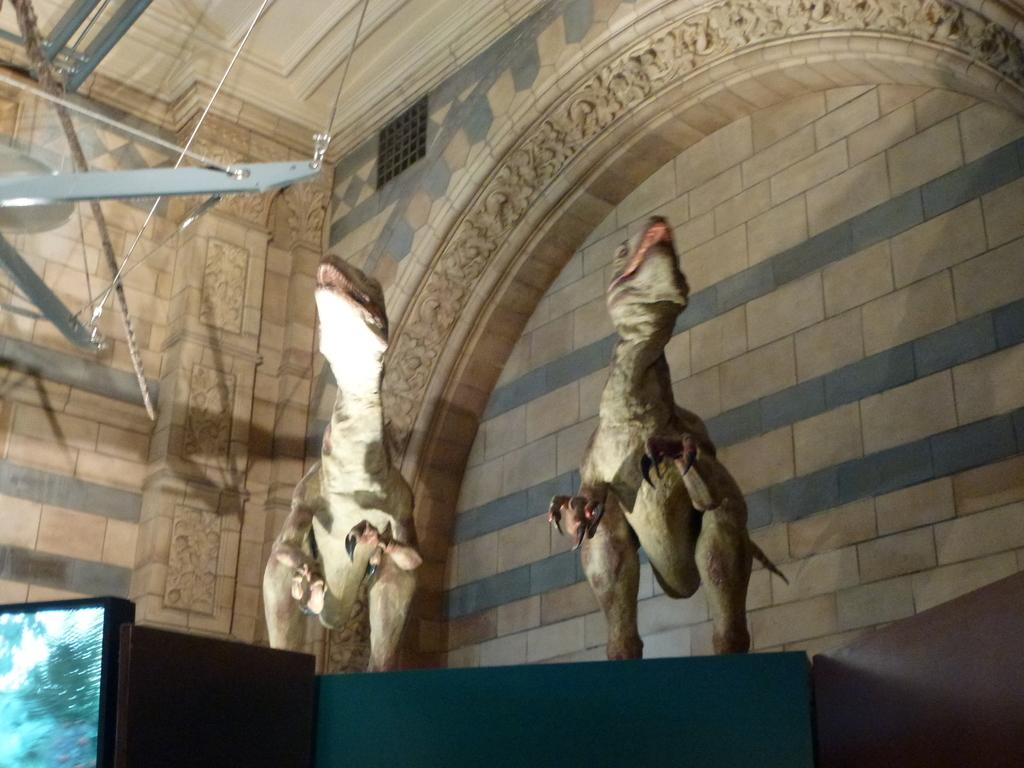What type of objects are depicted in the image? There are sculptures of dinosaurs in the image. What can be seen in the background of the image? There is a wall in the background of the image. What direction is the pan facing in the image? There is no pan present in the image. What type of straw is being used by the dinosaurs in the image? The image does not show any straws, as it features sculptures of dinosaurs and a wall in the background. 